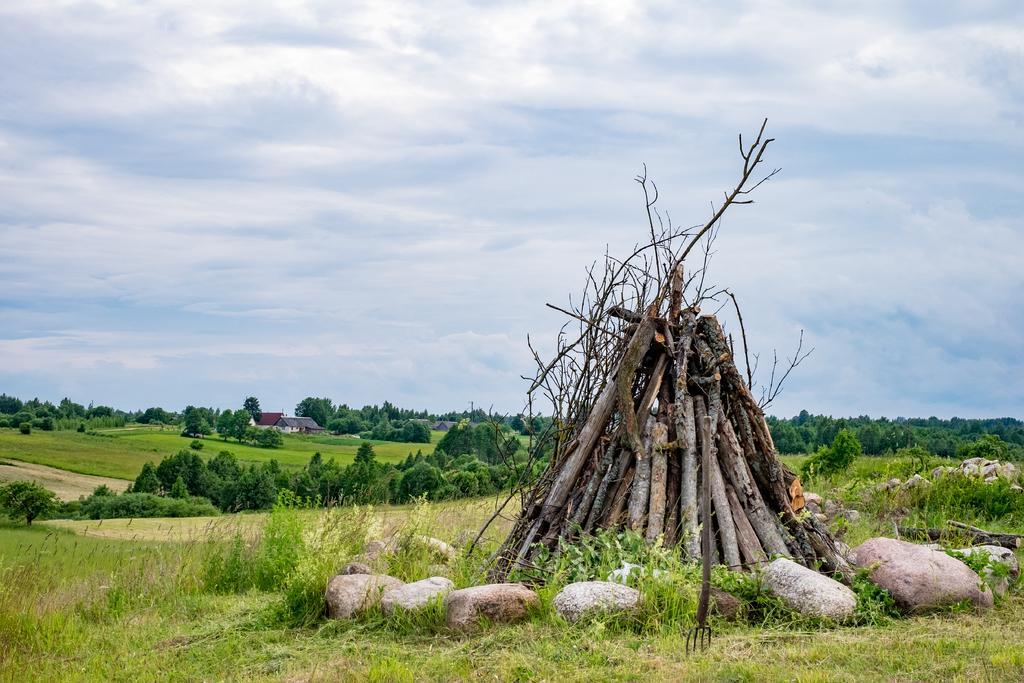In one or two sentences, can you explain what this image depicts? In this image we can see heap of logs and there are rocks. In the background there are trees, sheds and sky. At the bottom there is grass. 